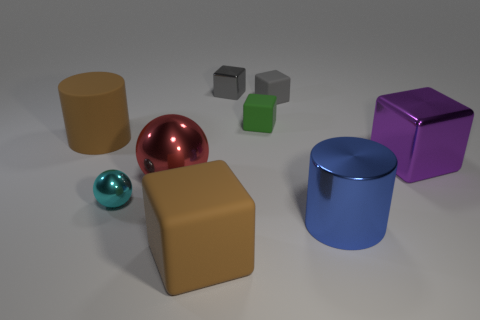Does the matte cylinder have the same color as the large rubber block?
Your response must be concise. Yes. What size is the brown rubber object that is the same shape as the purple object?
Make the answer very short. Large. What number of big purple cubes are the same material as the small ball?
Provide a short and direct response. 1. Is the number of blocks left of the red object less than the number of big yellow things?
Provide a succinct answer. No. What number of large purple metallic spheres are there?
Provide a succinct answer. 0. How many large spheres are the same color as the big metal block?
Your answer should be very brief. 0. Does the large red thing have the same shape as the cyan metal thing?
Offer a very short reply. Yes. What size is the gray thing left of the green cube behind the big brown cylinder?
Give a very brief answer. Small. Are there any yellow metal cylinders that have the same size as the brown rubber cube?
Give a very brief answer. No. There is a thing behind the tiny gray matte block; is its size the same as the gray matte thing that is behind the cyan shiny ball?
Offer a terse response. Yes. 